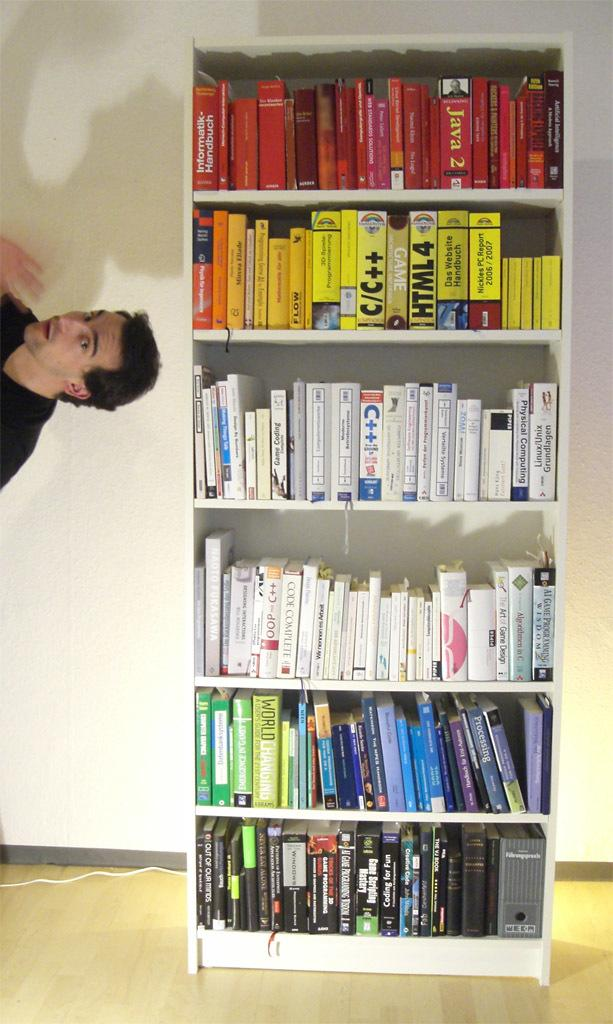Provide a one-sentence caption for the provided image. A man floats to the side of a bookcase with books like HTML 4. 